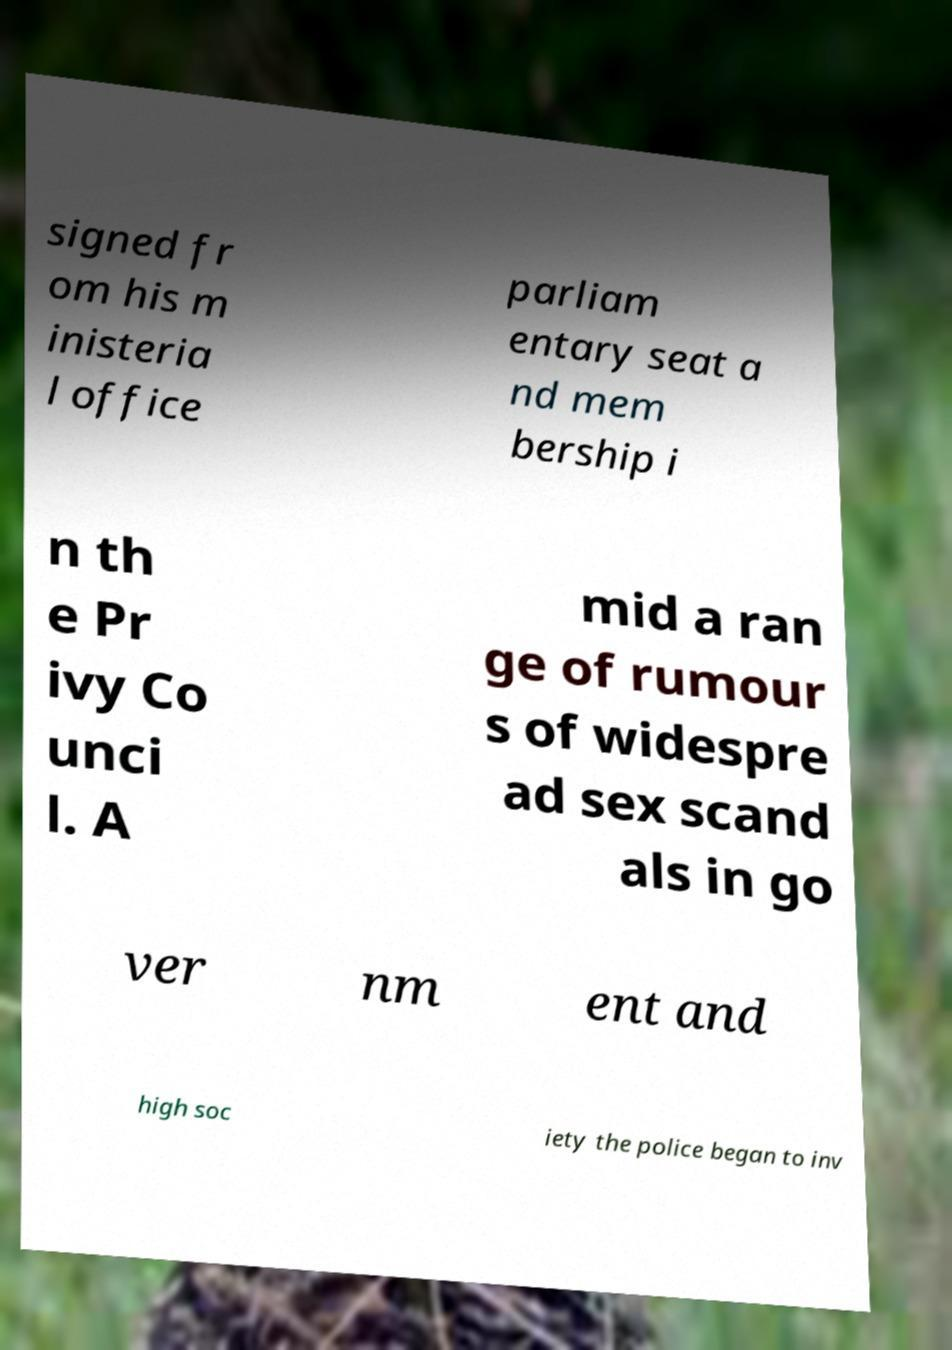Can you accurately transcribe the text from the provided image for me? signed fr om his m inisteria l office parliam entary seat a nd mem bership i n th e Pr ivy Co unci l. A mid a ran ge of rumour s of widespre ad sex scand als in go ver nm ent and high soc iety the police began to inv 